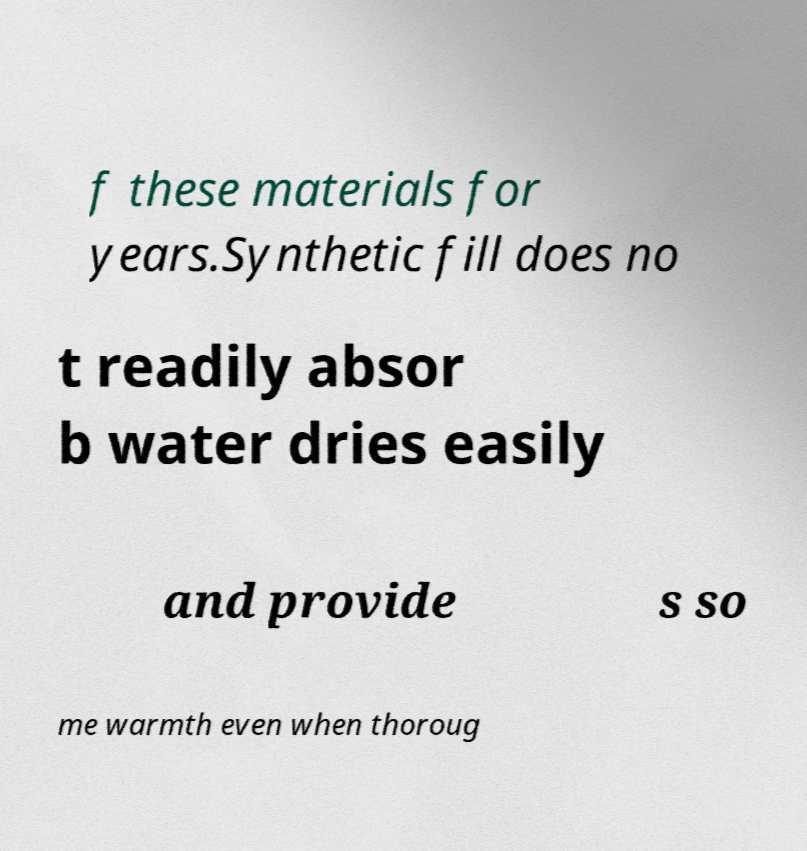Can you accurately transcribe the text from the provided image for me? f these materials for years.Synthetic fill does no t readily absor b water dries easily and provide s so me warmth even when thoroug 